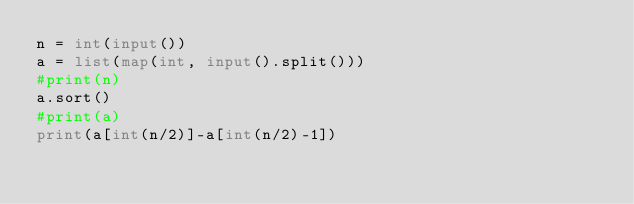Convert code to text. <code><loc_0><loc_0><loc_500><loc_500><_Python_>n = int(input())
a = list(map(int, input().split()))
#print(n)
a.sort()
#print(a)
print(a[int(n/2)]-a[int(n/2)-1])</code> 